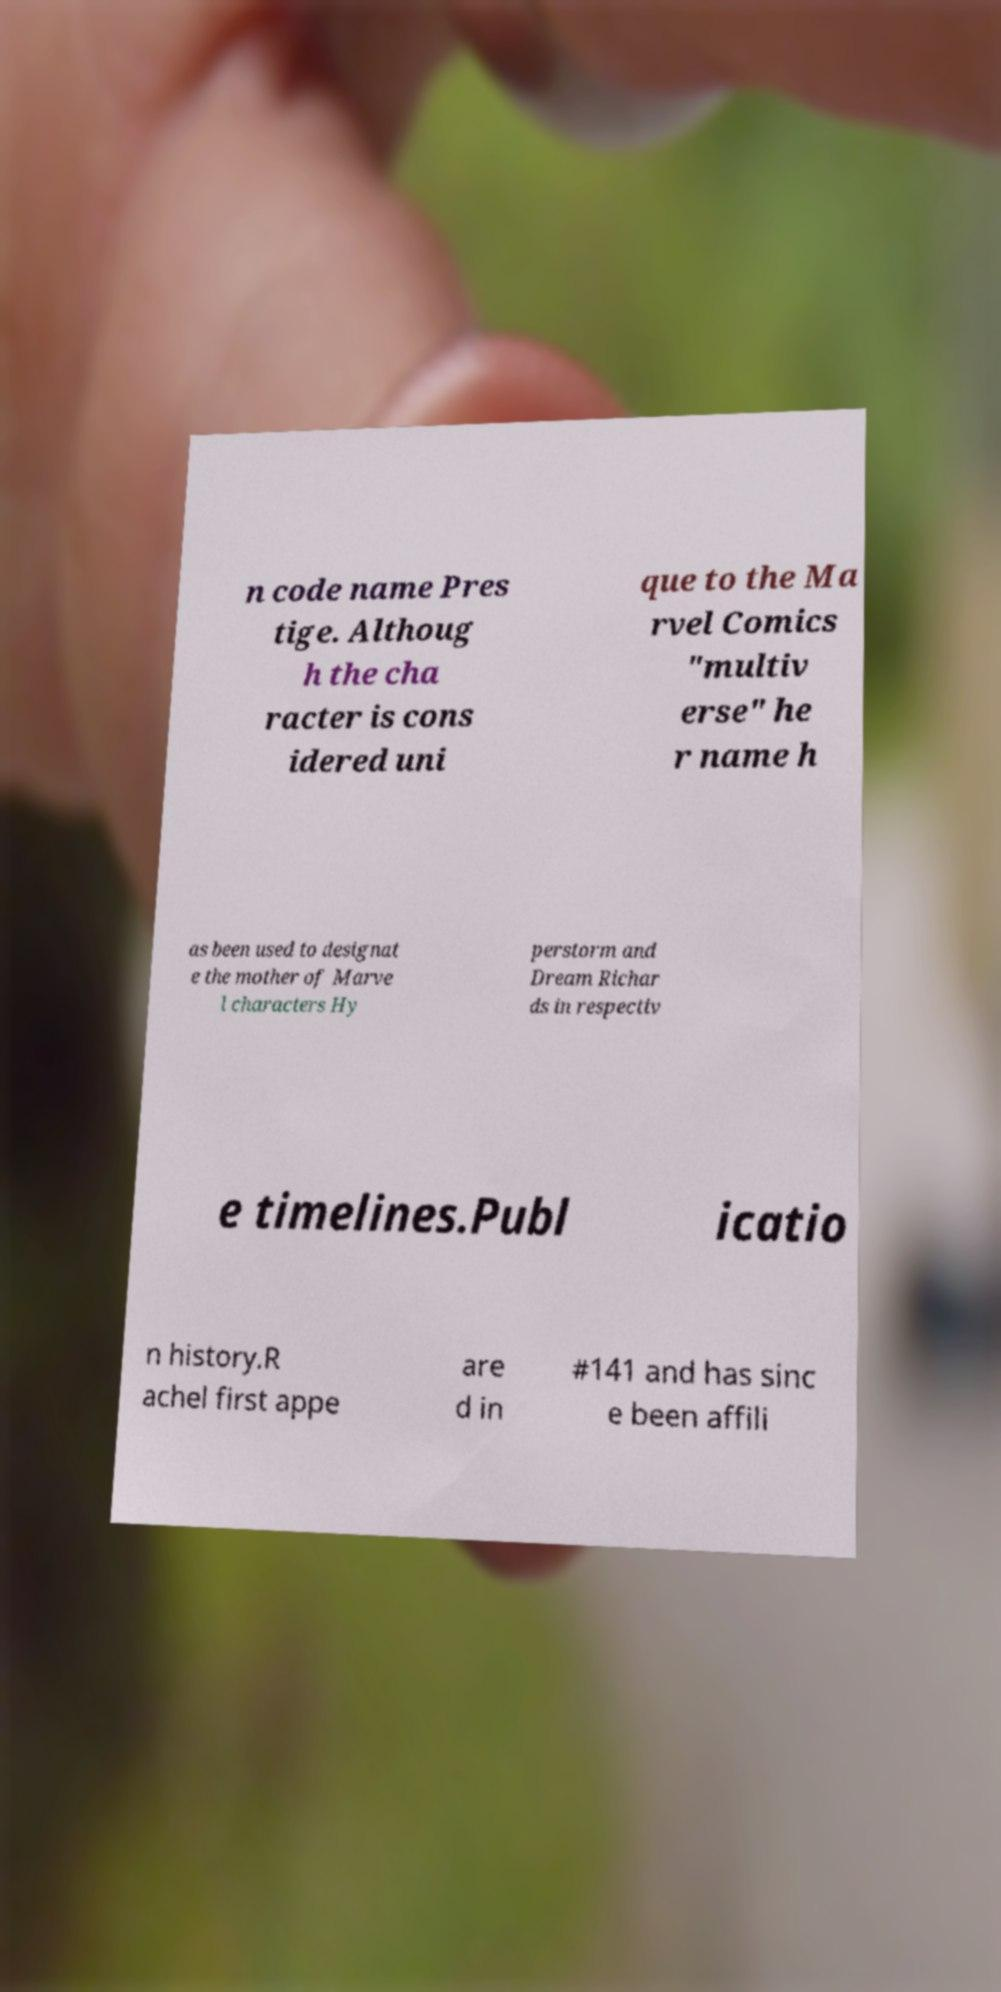Could you extract and type out the text from this image? n code name Pres tige. Althoug h the cha racter is cons idered uni que to the Ma rvel Comics "multiv erse" he r name h as been used to designat e the mother of Marve l characters Hy perstorm and Dream Richar ds in respectiv e timelines.Publ icatio n history.R achel first appe are d in #141 and has sinc e been affili 